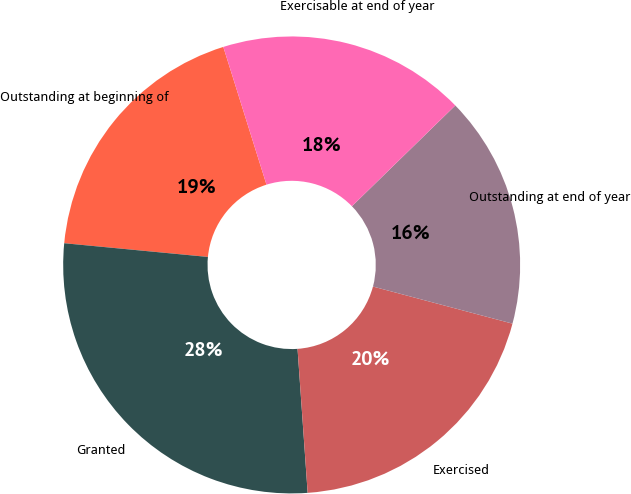Convert chart to OTSL. <chart><loc_0><loc_0><loc_500><loc_500><pie_chart><fcel>Outstanding at beginning of<fcel>Granted<fcel>Exercised<fcel>Outstanding at end of year<fcel>Exercisable at end of year<nl><fcel>18.65%<fcel>27.63%<fcel>19.75%<fcel>16.43%<fcel>17.54%<nl></chart> 